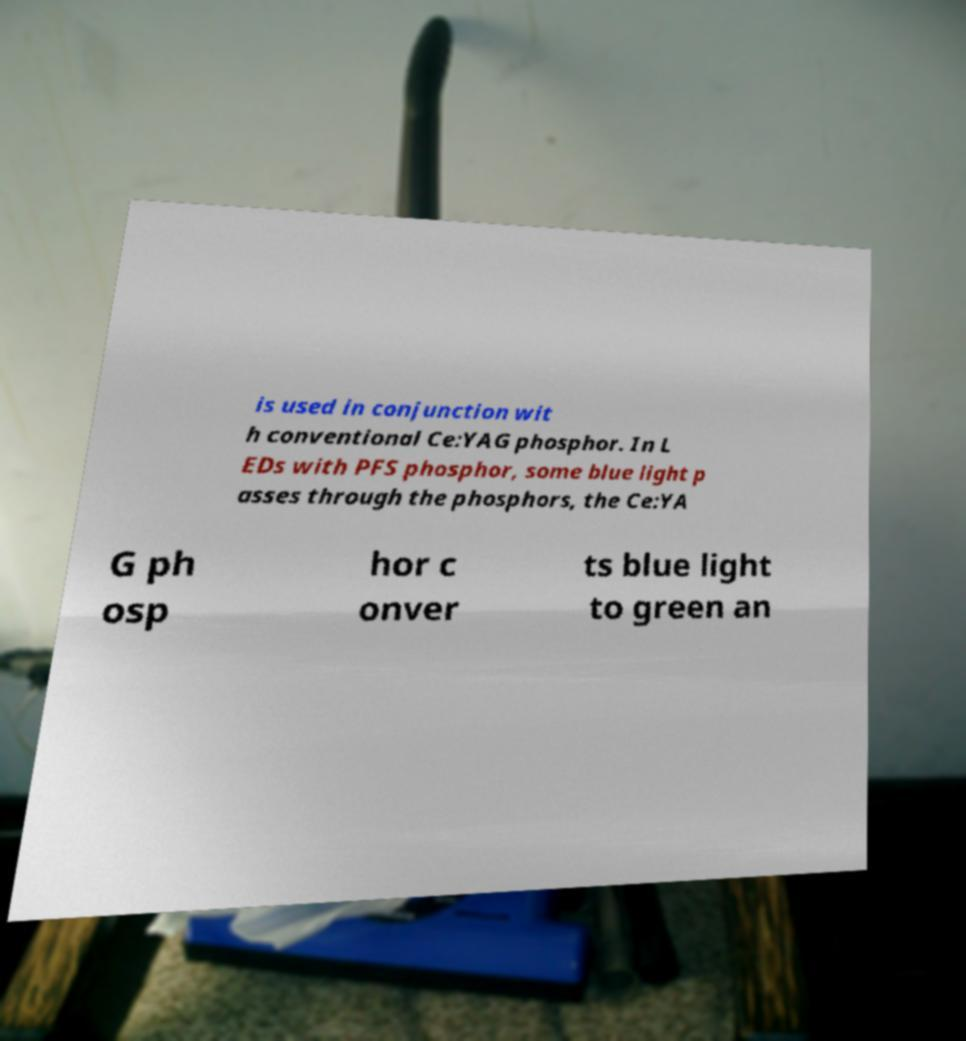Could you assist in decoding the text presented in this image and type it out clearly? is used in conjunction wit h conventional Ce:YAG phosphor. In L EDs with PFS phosphor, some blue light p asses through the phosphors, the Ce:YA G ph osp hor c onver ts blue light to green an 